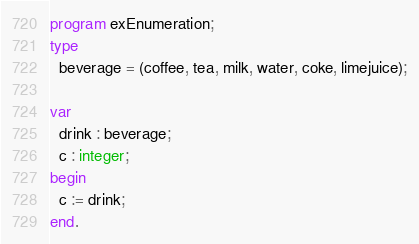<code> <loc_0><loc_0><loc_500><loc_500><_Pascal_>program exEnumeration;
type
  beverage = (coffee, tea, milk, water, coke, limejuice);

var
  drink : beverage;
  c : integer;
begin
  c := drink;
end.
</code> 